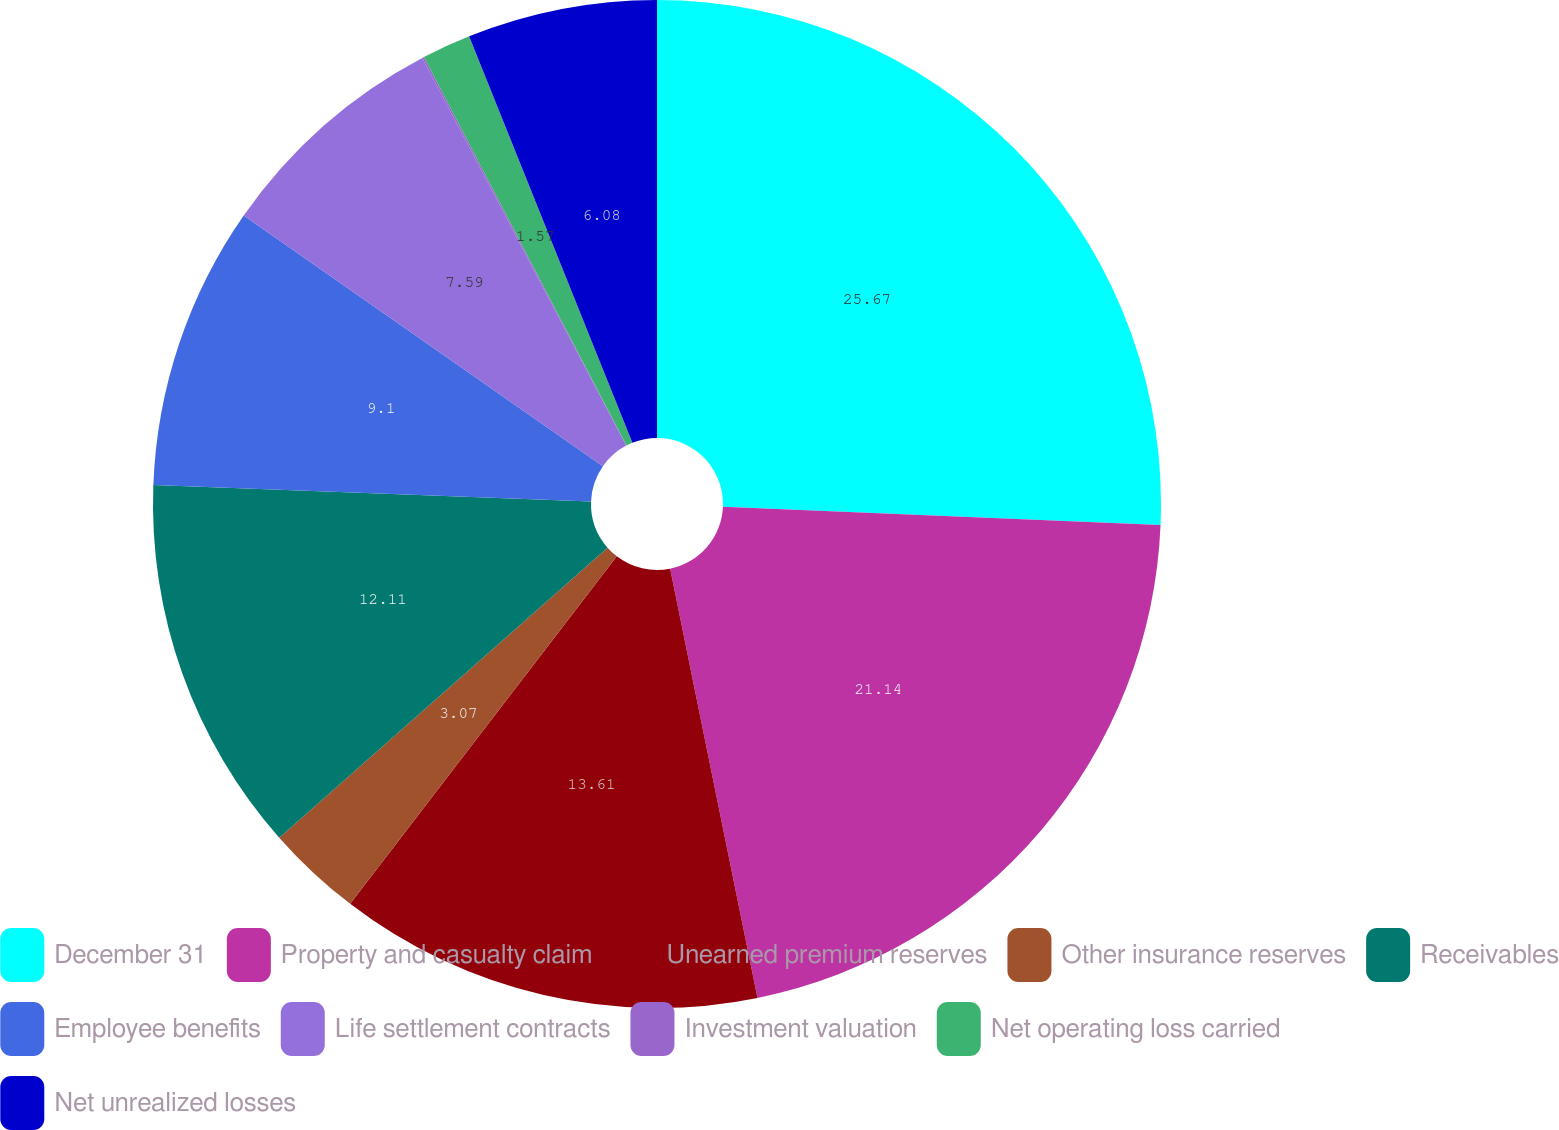Convert chart to OTSL. <chart><loc_0><loc_0><loc_500><loc_500><pie_chart><fcel>December 31<fcel>Property and casualty claim<fcel>Unearned premium reserves<fcel>Other insurance reserves<fcel>Receivables<fcel>Employee benefits<fcel>Life settlement contracts<fcel>Investment valuation<fcel>Net operating loss carried<fcel>Net unrealized losses<nl><fcel>25.66%<fcel>21.14%<fcel>13.61%<fcel>3.07%<fcel>12.11%<fcel>9.1%<fcel>7.59%<fcel>0.06%<fcel>1.57%<fcel>6.08%<nl></chart> 